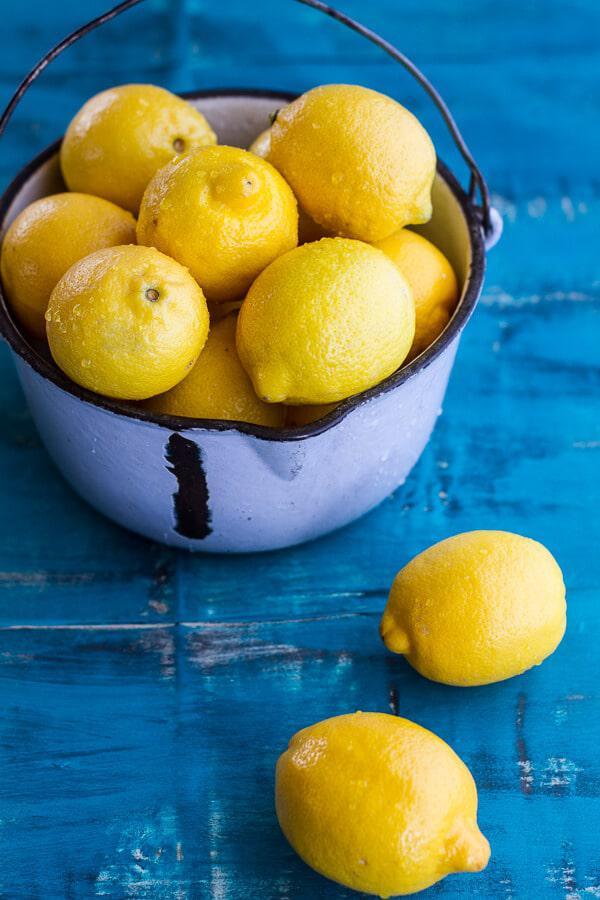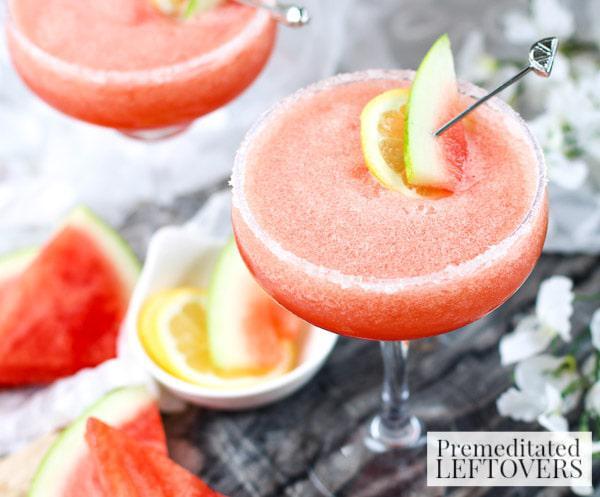The first image is the image on the left, the second image is the image on the right. For the images displayed, is the sentence "At least one image features more than one whole lemon." factually correct? Answer yes or no. Yes. 